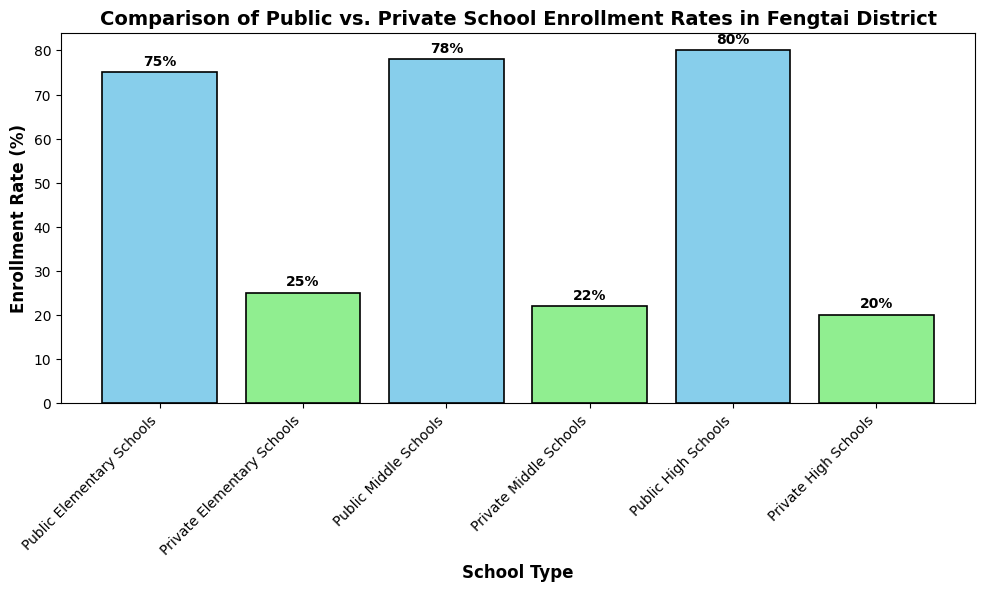Which school type has the highest enrollment rate for high schools? The bar representing Public High Schools has the highest enrollment rate at 80%.
Answer: Public High Schools What is the combined enrollment rate for Public Elementary Schools and Private Middle Schools? Add the enrollment rates for Public Elementary Schools (75%) and Private Middle Schools (22%): 75 + 22 = 97%.
Answer: 97% Which has a higher enrollment rate, Private Elementary Schools or Private Middle Schools? Compare the enrollment rates: Private Elementary Schools at 25% and Private Middle Schools at 22%. 25% is greater than 22%.
Answer: Private Elementary Schools What is the difference in enrollment rates between Public and Private High Schools? Subtract the enrollment rate of Private High Schools (20%) from Public High Schools (80%): 80 - 20 = 60%.
Answer: 60% How does the enrollment rate of Public Middle Schools compare to Private High Schools? The enrollment rate for Public Middle Schools is 78%, and for Private High Schools, it is 20%. 78% is much higher than 20%.
Answer: Public Middle Schools have a higher enrollment rate Among all school types, which has the lowest enrollment rate? The bar for Private Middle Schools has the lowest enrollment rate at 22%.
Answer: Private Middle Schools What is the average enrollment rate of private schools across all levels? Add the enrollment rates for Private Elementary Schools (25%), Private Middle Schools (22%), and Private High Schools (20%), and divide by 3. (25 + 22 + 20) / 3 = 22.33%.
Answer: 22.33% Which category has the most similar enrollment rates between public and private schools? Compare the differences: Elementary (75%-25%=50%), Middle (78%-22%=56%), High (80%-20%=60%). The smallest difference is in Elementary Schools.
Answer: Elementary Schools Looking at the colors, which type of schools are represented by sky blue bars? The sky blue bars represent Public Schools (Elementary, Middle, and High schools, based on the pattern).
Answer: Public Schools What is the enrollment rate difference between the highest and lowest enrollment rates in the chart? The highest enrollment rate is Public High Schools at 80%, and the lowest is Private Middle Schools at 22%. Difference: 80 - 22 = 58%.
Answer: 58% 